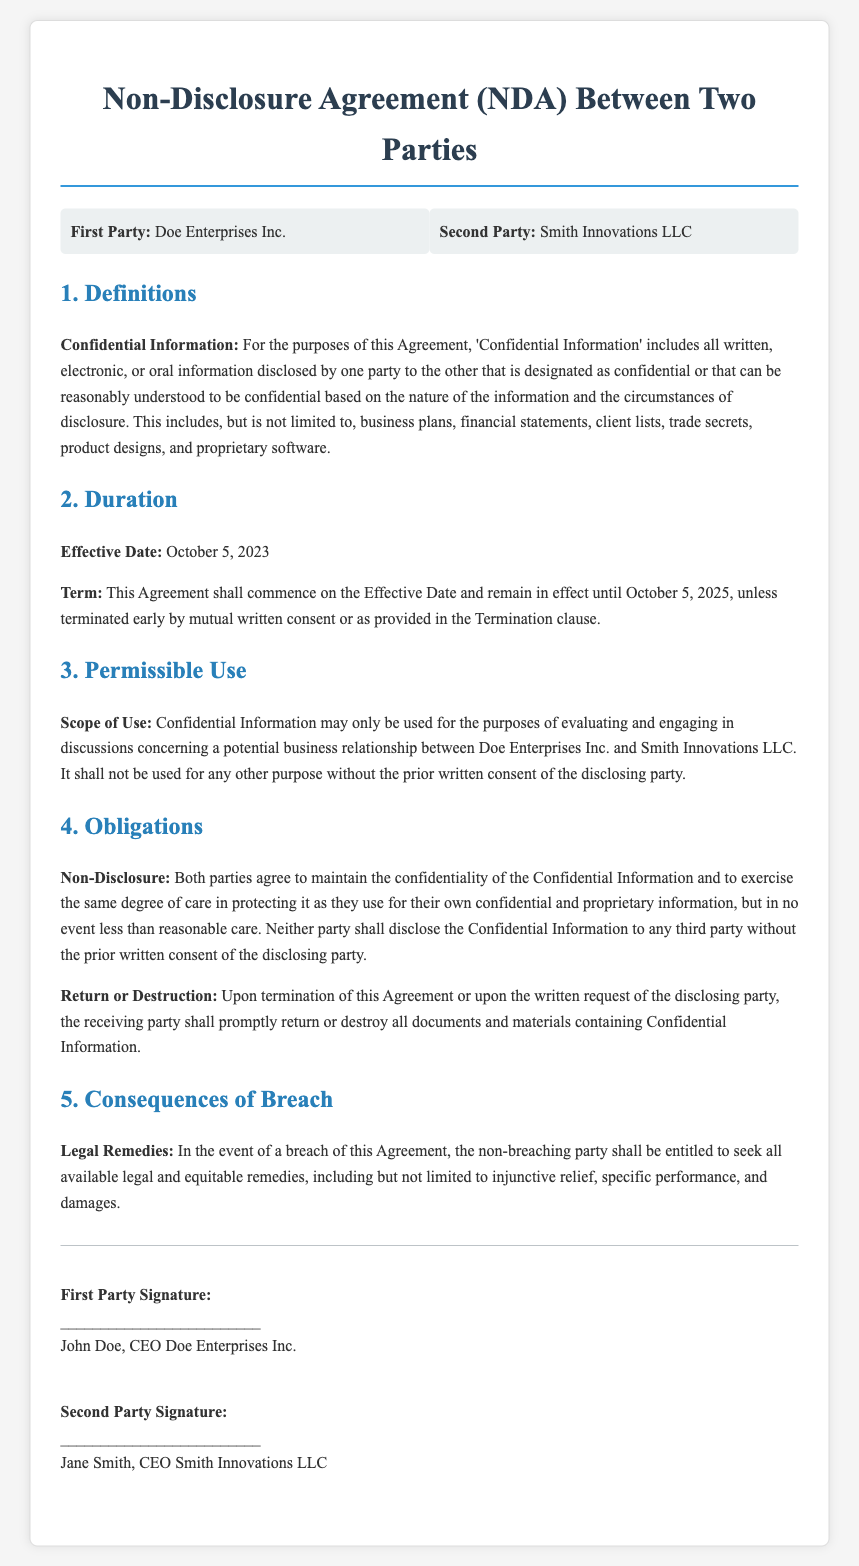What is the name of the first party? The first party is identified as Doe Enterprises Inc. in the document.
Answer: Doe Enterprises Inc What is the name of the second party? The second party is identified as Smith Innovations LLC in the document.
Answer: Smith Innovations LLC What is the effective date of the agreement? The document states the effective date as October 5, 2023.
Answer: October 5, 2023 What is the term duration of the agreement? The agreement's term lasts until October 5, 2025, unless terminated early.
Answer: October 5, 2025 What must the receiving party do upon termination? The receiving party is required to return or destroy all documents containing Confidential Information.
Answer: Return or destroy What kind of remedies are available in case of a breach? The document specifies that the non-breaching party may seek legal and equitable remedies, including injunctive relief and damages.
Answer: Legal and equitable remedies What is considered "Confidential Information"? Confidential Information includes all information disclosed that is designated as confidential based on the circumstances of disclosure.
Answer: All information disclosed For what purpose can Confidential Information be used? Confidential Information may only be used to evaluate and engage in discussions concerning a potential business relationship.
Answer: Evaluating a potential business relationship What degree of care must be exercised in maintaining confidentiality? The parties must exercise at least reasonable care in protecting Confidential Information.
Answer: Reasonable care 